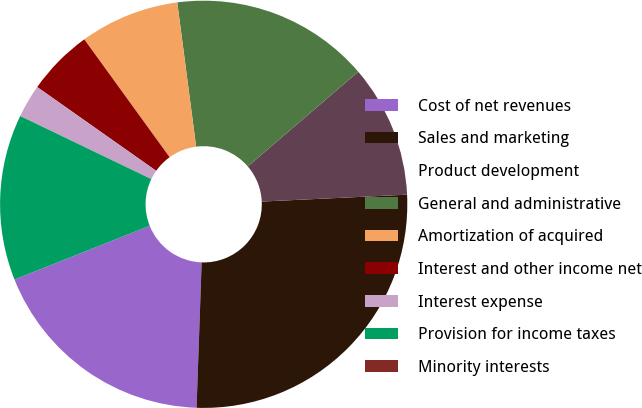<chart> <loc_0><loc_0><loc_500><loc_500><pie_chart><fcel>Cost of net revenues<fcel>Sales and marketing<fcel>Product development<fcel>General and administrative<fcel>Amortization of acquired<fcel>Interest and other income net<fcel>Interest expense<fcel>Provision for income taxes<fcel>Minority interests<nl><fcel>18.42%<fcel>26.31%<fcel>10.53%<fcel>15.79%<fcel>7.9%<fcel>5.26%<fcel>2.63%<fcel>13.16%<fcel>0.0%<nl></chart> 